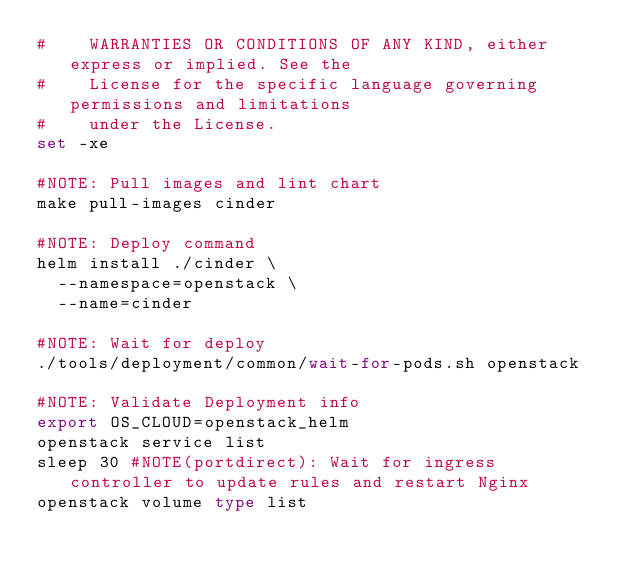Convert code to text. <code><loc_0><loc_0><loc_500><loc_500><_Bash_>#    WARRANTIES OR CONDITIONS OF ANY KIND, either express or implied. See the
#    License for the specific language governing permissions and limitations
#    under the License.
set -xe

#NOTE: Pull images and lint chart
make pull-images cinder

#NOTE: Deploy command
helm install ./cinder \
  --namespace=openstack \
  --name=cinder

#NOTE: Wait for deploy
./tools/deployment/common/wait-for-pods.sh openstack

#NOTE: Validate Deployment info
export OS_CLOUD=openstack_helm
openstack service list
sleep 30 #NOTE(portdirect): Wait for ingress controller to update rules and restart Nginx
openstack volume type list
</code> 